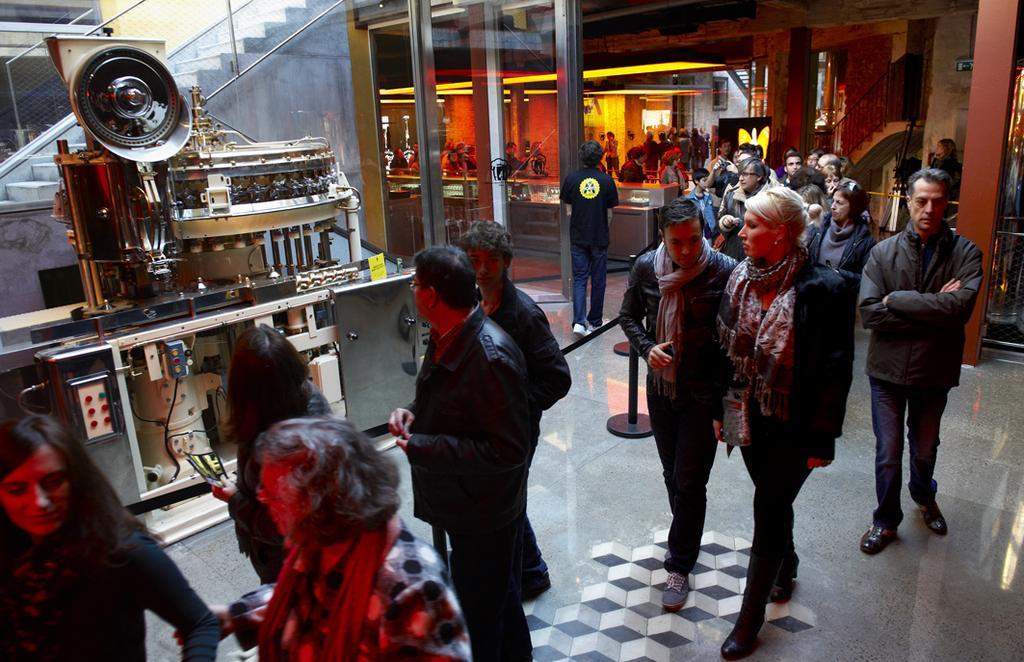Please provide a concise description of this image. In this image I can see the group of people with different color dresses. To the left I can see the fencing rope and machine. I can also see the railing and stairs to the left. In the background I can see few more people and the board. 